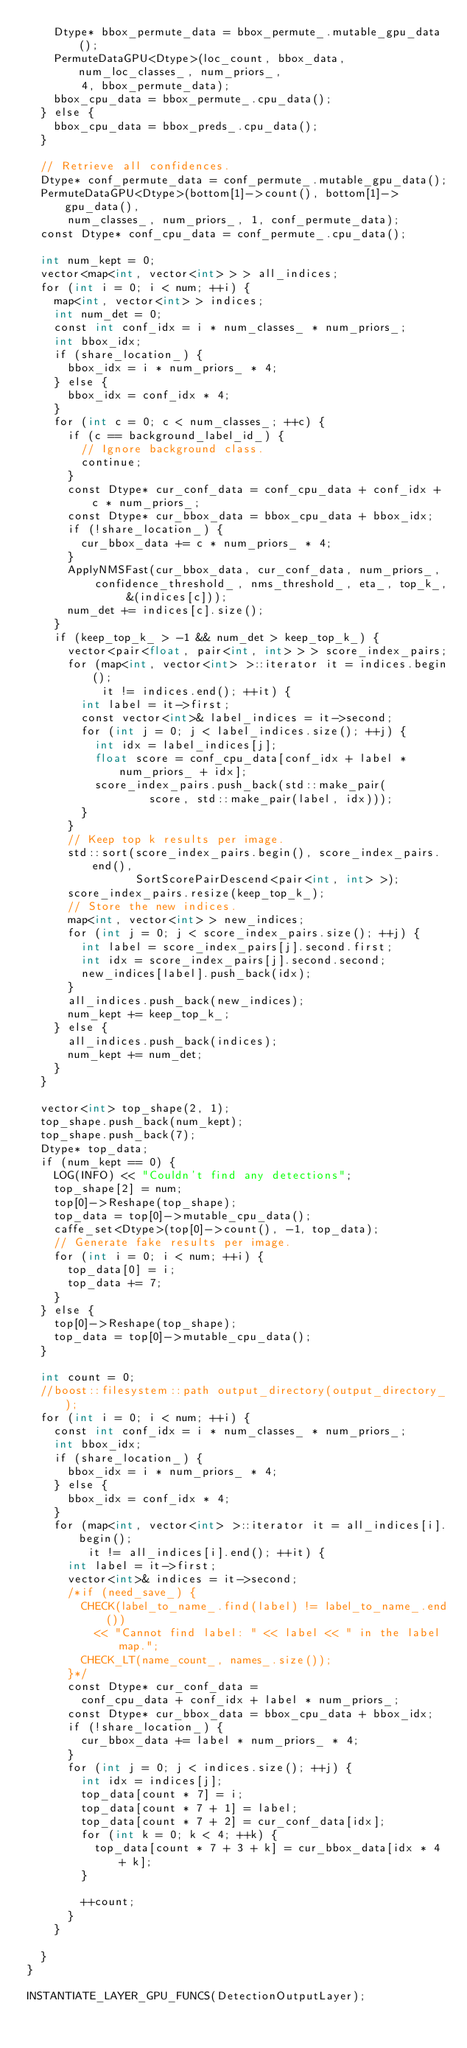<code> <loc_0><loc_0><loc_500><loc_500><_Cuda_>    Dtype* bbox_permute_data = bbox_permute_.mutable_gpu_data();
    PermuteDataGPU<Dtype>(loc_count, bbox_data, num_loc_classes_, num_priors_,
        4, bbox_permute_data);
    bbox_cpu_data = bbox_permute_.cpu_data();
  } else {
    bbox_cpu_data = bbox_preds_.cpu_data();
  }

  // Retrieve all confidences.
  Dtype* conf_permute_data = conf_permute_.mutable_gpu_data();
  PermuteDataGPU<Dtype>(bottom[1]->count(), bottom[1]->gpu_data(),
      num_classes_, num_priors_, 1, conf_permute_data);
  const Dtype* conf_cpu_data = conf_permute_.cpu_data();

  int num_kept = 0;
  vector<map<int, vector<int> > > all_indices;
  for (int i = 0; i < num; ++i) {
    map<int, vector<int> > indices;
    int num_det = 0;
    const int conf_idx = i * num_classes_ * num_priors_;
    int bbox_idx;
    if (share_location_) {
      bbox_idx = i * num_priors_ * 4;
    } else {
      bbox_idx = conf_idx * 4;
    }
    for (int c = 0; c < num_classes_; ++c) {
      if (c == background_label_id_) {
        // Ignore background class.
        continue;
      }
      const Dtype* cur_conf_data = conf_cpu_data + conf_idx + c * num_priors_;
      const Dtype* cur_bbox_data = bbox_cpu_data + bbox_idx;
      if (!share_location_) {
        cur_bbox_data += c * num_priors_ * 4;
      }
      ApplyNMSFast(cur_bbox_data, cur_conf_data, num_priors_,
          confidence_threshold_, nms_threshold_, eta_, top_k_, &(indices[c]));
      num_det += indices[c].size();
    }
    if (keep_top_k_ > -1 && num_det > keep_top_k_) {
      vector<pair<float, pair<int, int> > > score_index_pairs;
      for (map<int, vector<int> >::iterator it = indices.begin();
           it != indices.end(); ++it) {
        int label = it->first;
        const vector<int>& label_indices = it->second;
        for (int j = 0; j < label_indices.size(); ++j) {
          int idx = label_indices[j];
          float score = conf_cpu_data[conf_idx + label * num_priors_ + idx];
          score_index_pairs.push_back(std::make_pair(
                  score, std::make_pair(label, idx)));
        }
      }
      // Keep top k results per image.
      std::sort(score_index_pairs.begin(), score_index_pairs.end(),
                SortScorePairDescend<pair<int, int> >);
      score_index_pairs.resize(keep_top_k_);
      // Store the new indices.
      map<int, vector<int> > new_indices;
      for (int j = 0; j < score_index_pairs.size(); ++j) {
        int label = score_index_pairs[j].second.first;
        int idx = score_index_pairs[j].second.second;
        new_indices[label].push_back(idx);
      }
      all_indices.push_back(new_indices);
      num_kept += keep_top_k_;
    } else {
      all_indices.push_back(indices);
      num_kept += num_det;
    }
  }

  vector<int> top_shape(2, 1);
  top_shape.push_back(num_kept);
  top_shape.push_back(7);
  Dtype* top_data;
  if (num_kept == 0) {
    LOG(INFO) << "Couldn't find any detections";
    top_shape[2] = num;
    top[0]->Reshape(top_shape);
    top_data = top[0]->mutable_cpu_data();
    caffe_set<Dtype>(top[0]->count(), -1, top_data);
    // Generate fake results per image.
    for (int i = 0; i < num; ++i) {
      top_data[0] = i;
      top_data += 7;
    }
  } else {
    top[0]->Reshape(top_shape);
    top_data = top[0]->mutable_cpu_data();
  }

  int count = 0;
  //boost::filesystem::path output_directory(output_directory_);
  for (int i = 0; i < num; ++i) {
    const int conf_idx = i * num_classes_ * num_priors_;
    int bbox_idx;
    if (share_location_) {
      bbox_idx = i * num_priors_ * 4;
    } else {
      bbox_idx = conf_idx * 4;
    }
    for (map<int, vector<int> >::iterator it = all_indices[i].begin();
         it != all_indices[i].end(); ++it) {
      int label = it->first;
      vector<int>& indices = it->second;
      /*if (need_save_) {
        CHECK(label_to_name_.find(label) != label_to_name_.end())
          << "Cannot find label: " << label << " in the label map.";
        CHECK_LT(name_count_, names_.size());
      }*/
      const Dtype* cur_conf_data =
        conf_cpu_data + conf_idx + label * num_priors_;
      const Dtype* cur_bbox_data = bbox_cpu_data + bbox_idx;
      if (!share_location_) {
        cur_bbox_data += label * num_priors_ * 4;
      }
      for (int j = 0; j < indices.size(); ++j) {
        int idx = indices[j];
        top_data[count * 7] = i;
        top_data[count * 7 + 1] = label;
        top_data[count * 7 + 2] = cur_conf_data[idx];
        for (int k = 0; k < 4; ++k) {
          top_data[count * 7 + 3 + k] = cur_bbox_data[idx * 4 + k];
        }
        
        ++count;
      }
    }
    
  }
}

INSTANTIATE_LAYER_GPU_FUNCS(DetectionOutputLayer);
</code> 